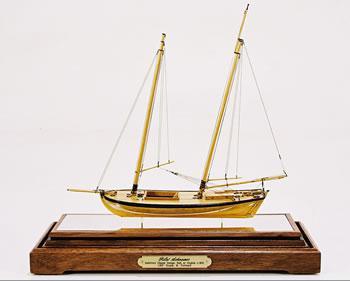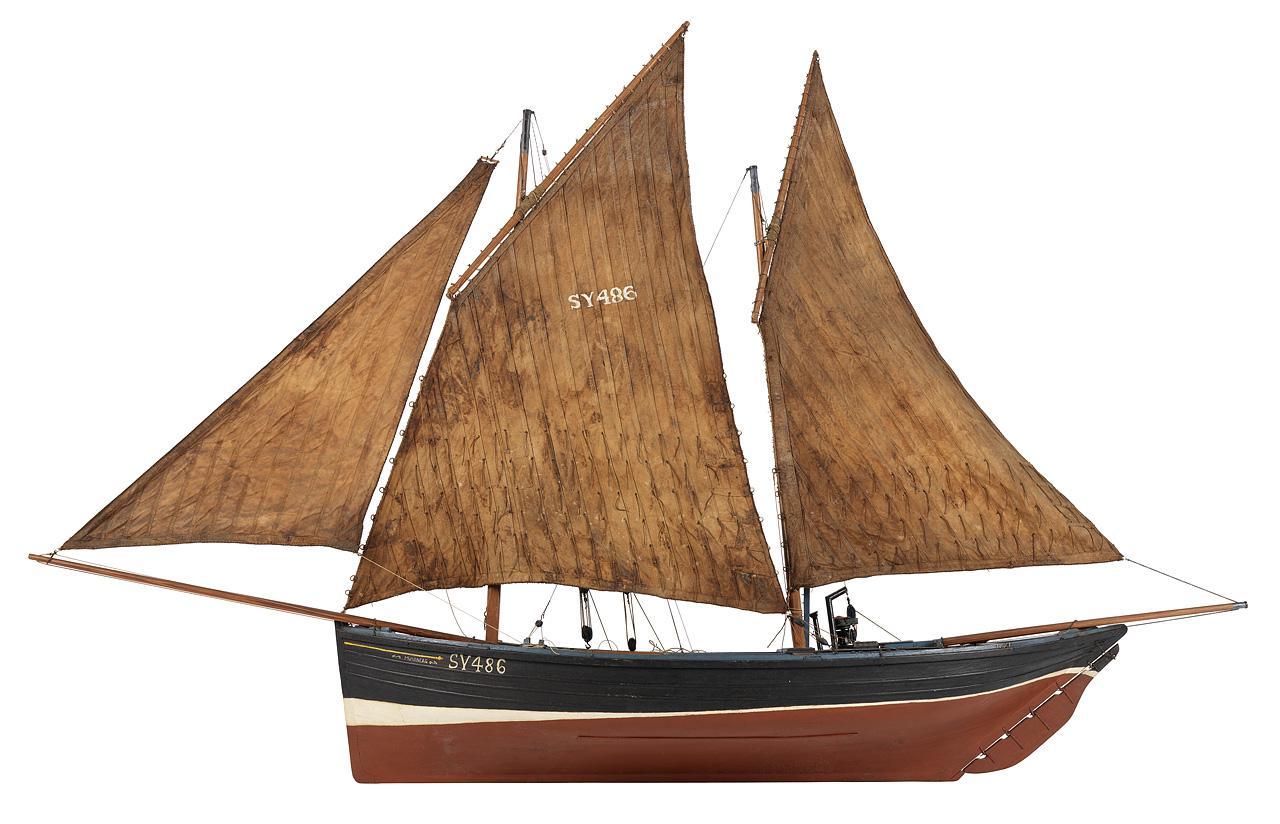The first image is the image on the left, the second image is the image on the right. Examine the images to the left and right. Is the description "Two sailboat models are sitting on matching stands." accurate? Answer yes or no. No. The first image is the image on the left, the second image is the image on the right. Evaluate the accuracy of this statement regarding the images: "Right image features a boat with only brown sails.". Is it true? Answer yes or no. Yes. 